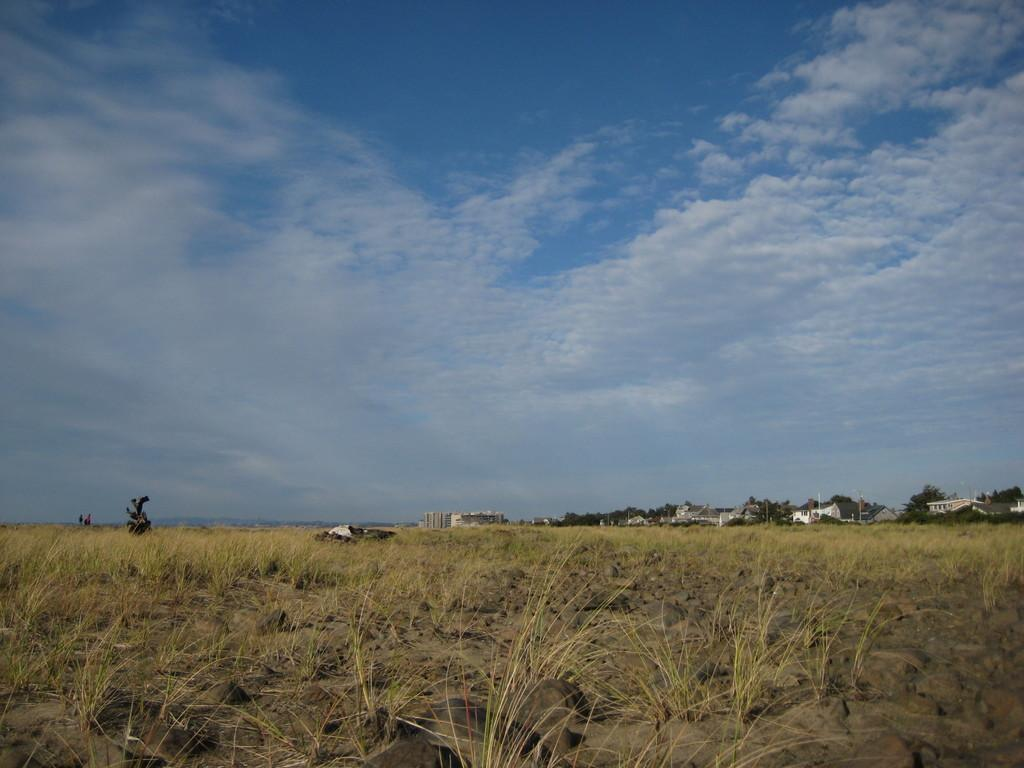What type of vegetation is at the bottom of the image? There is grass at the bottom of the image. What can be seen in the background of the image? There are trees, buildings, and poles in the background of the image. What is visible at the top of the image? The sky is visible at the top of the image. How many cars are parked on the grass in the image? There are no cars present in the image; it features grass, trees, buildings, poles, and the sky. Can you see a horse grazing on the grass in the image? There is no horse present in the image. 